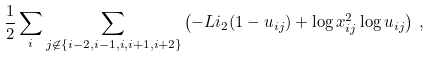<formula> <loc_0><loc_0><loc_500><loc_500>\frac { 1 } { 2 } \sum _ { i } \sum _ { j \not \in \{ i - 2 , i - 1 , i , i + 1 , i + 2 \} } \left ( - L i _ { 2 } ( 1 - u _ { i j } ) + \log x _ { i j } ^ { 2 } \log u _ { i j } \right ) \, ,</formula> 